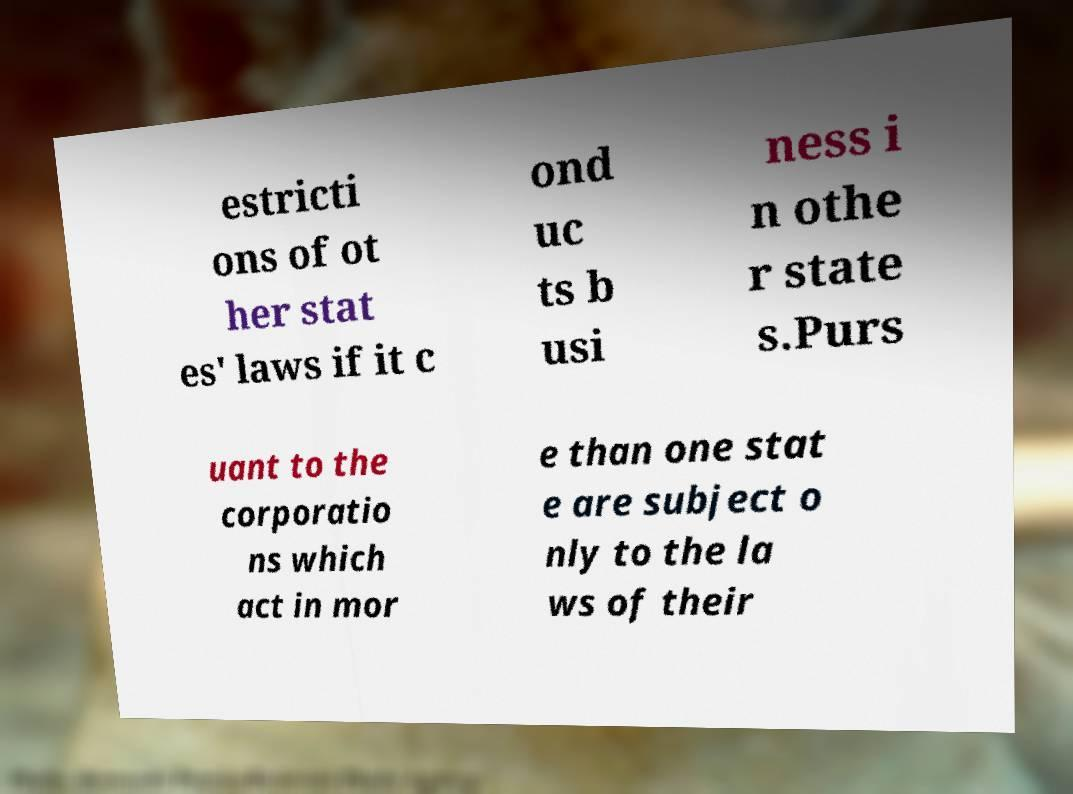Please identify and transcribe the text found in this image. estricti ons of ot her stat es' laws if it c ond uc ts b usi ness i n othe r state s.Purs uant to the corporatio ns which act in mor e than one stat e are subject o nly to the la ws of their 